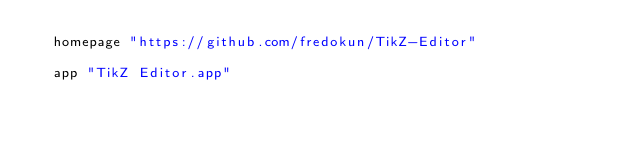Convert code to text. <code><loc_0><loc_0><loc_500><loc_500><_Ruby_>  homepage "https://github.com/fredokun/TikZ-Editor"

  app "TikZ Editor.app"</code> 